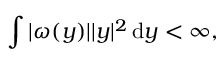Convert formula to latex. <formula><loc_0><loc_0><loc_500><loc_500>\int | \omega ( y ) | | y | ^ { 2 } \, d y < \infty ,</formula> 